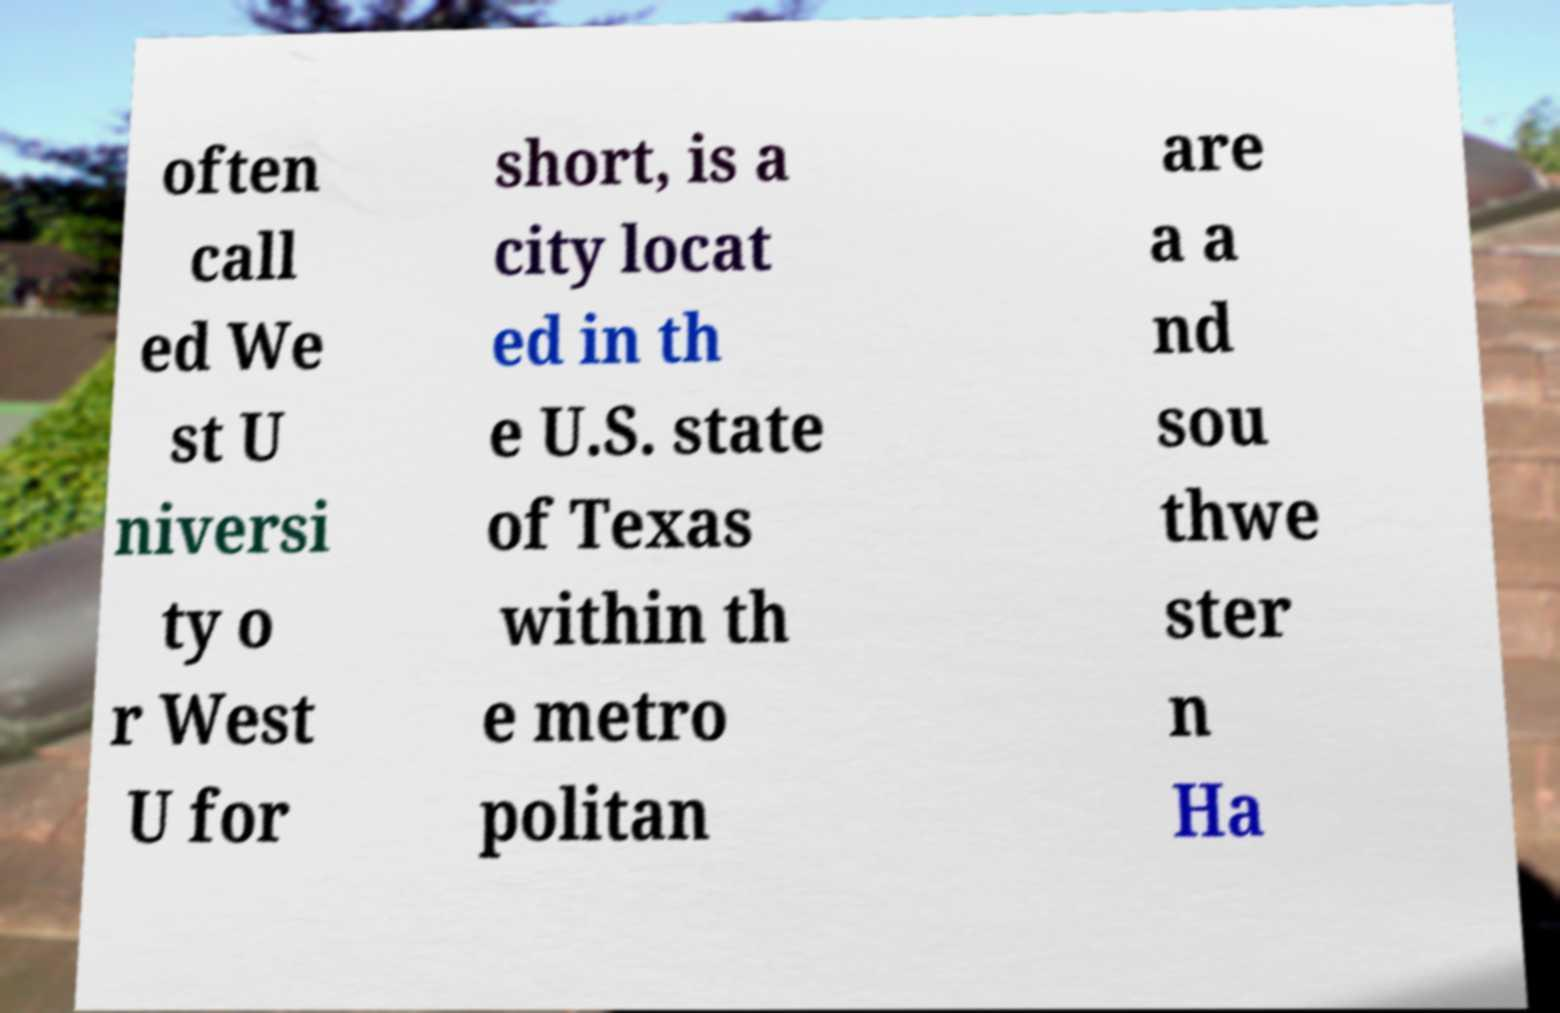Can you accurately transcribe the text from the provided image for me? often call ed We st U niversi ty o r West U for short, is a city locat ed in th e U.S. state of Texas within th e metro politan are a a nd sou thwe ster n Ha 